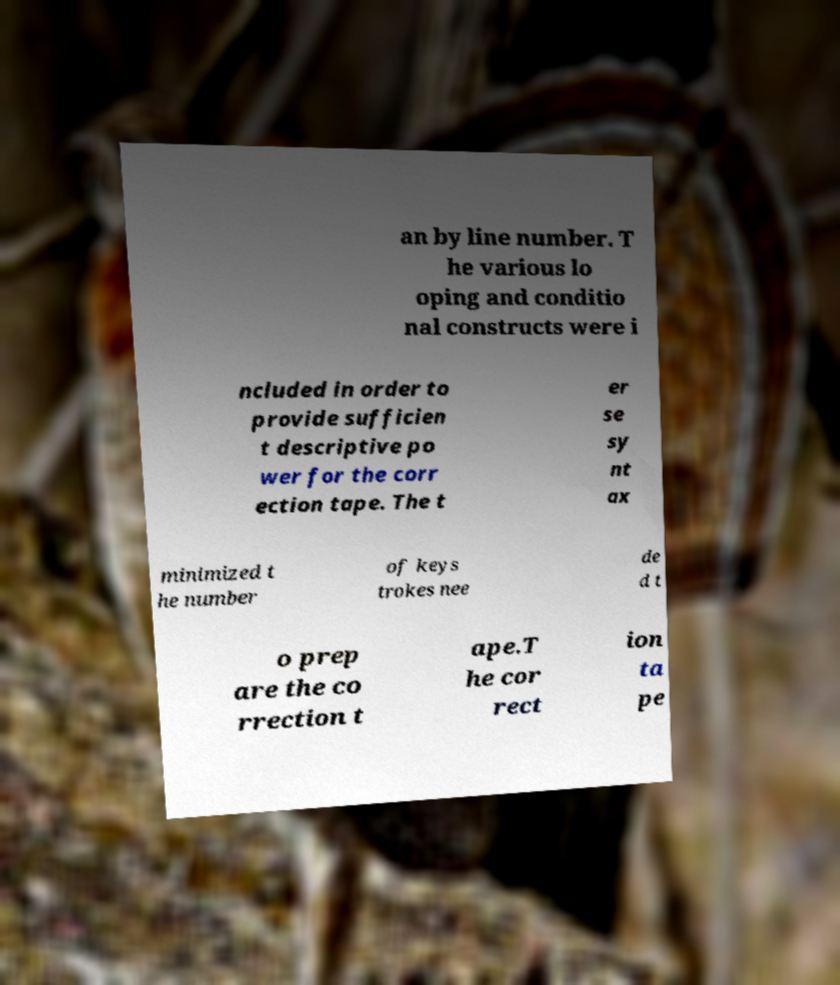There's text embedded in this image that I need extracted. Can you transcribe it verbatim? an by line number. T he various lo oping and conditio nal constructs were i ncluded in order to provide sufficien t descriptive po wer for the corr ection tape. The t er se sy nt ax minimized t he number of keys trokes nee de d t o prep are the co rrection t ape.T he cor rect ion ta pe 